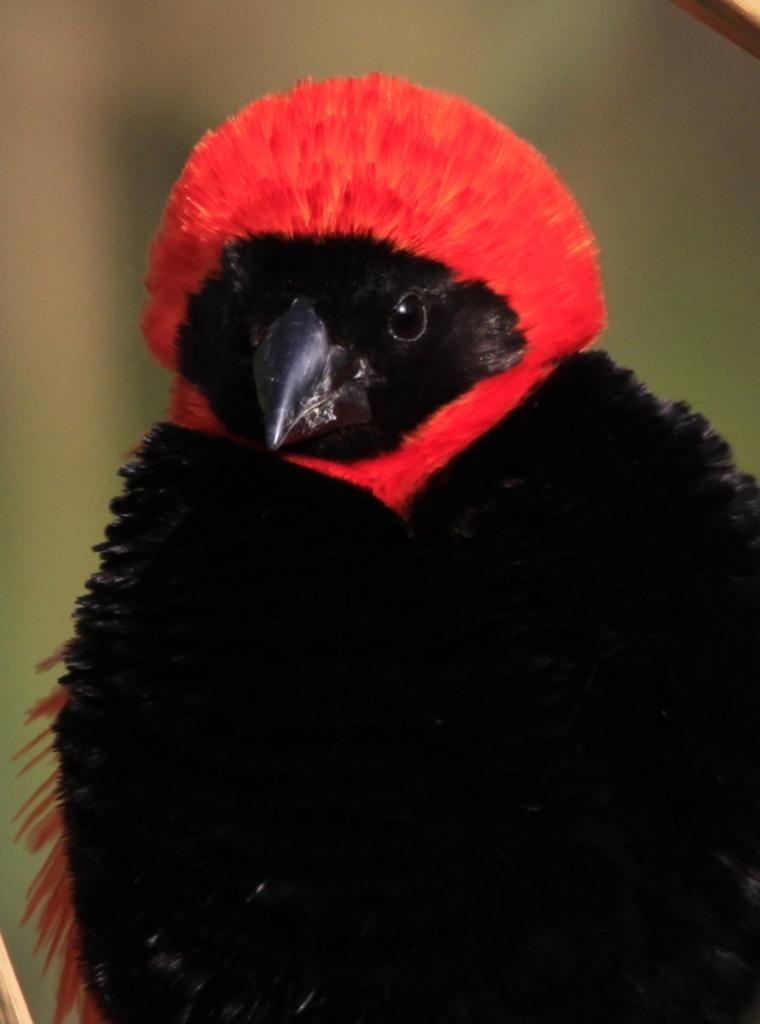What is the main subject of the image? There is a bird in the center of the image. Can you describe the bird in the image? The bird is the main focus of the image, but no specific details about its appearance or behavior are provided. What is the bird's position in the image? The bird is in the center of the image. How many times does the bird fall in the image? There is no indication in the image that the bird is falling or has fallen. What is the amount of yoke the bird is carrying in the image? There is no yoke present in the image, and therefore no amount can be determined. 